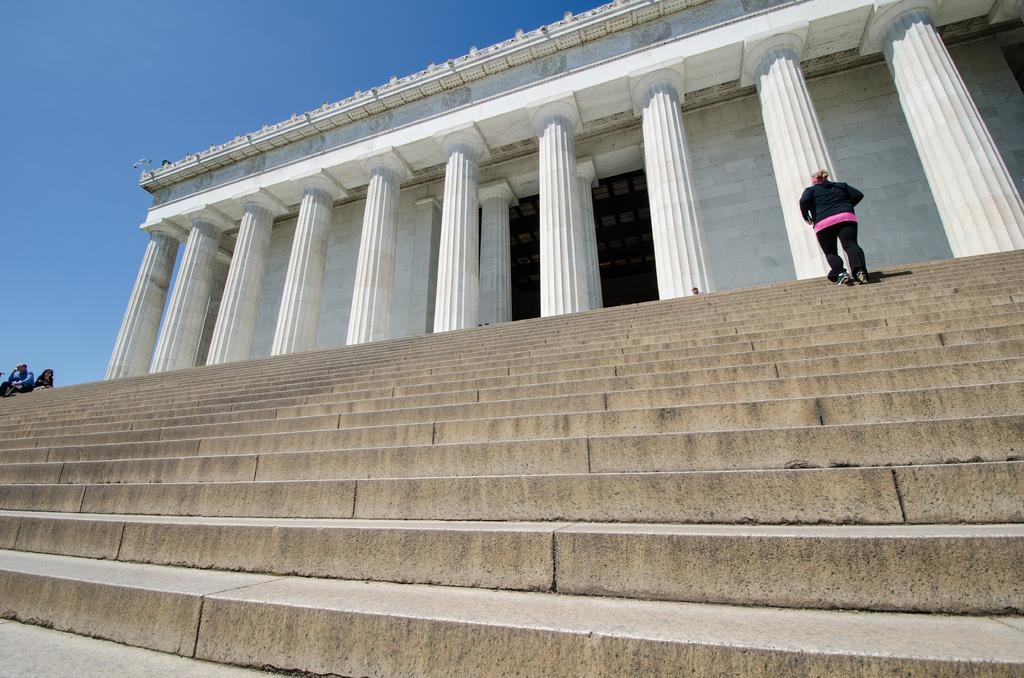What type of structure is in the image? There is a building in the image. What is located in front of the building? There is a staircase in front of the building. Can you describe the person visible in the image? A person is visible on the staircase. What is visible at the top of the image? The sky is visible at the top of the image. What type of goose is sitting on the manager's finger in the image? There is no goose or manager present in the image. 